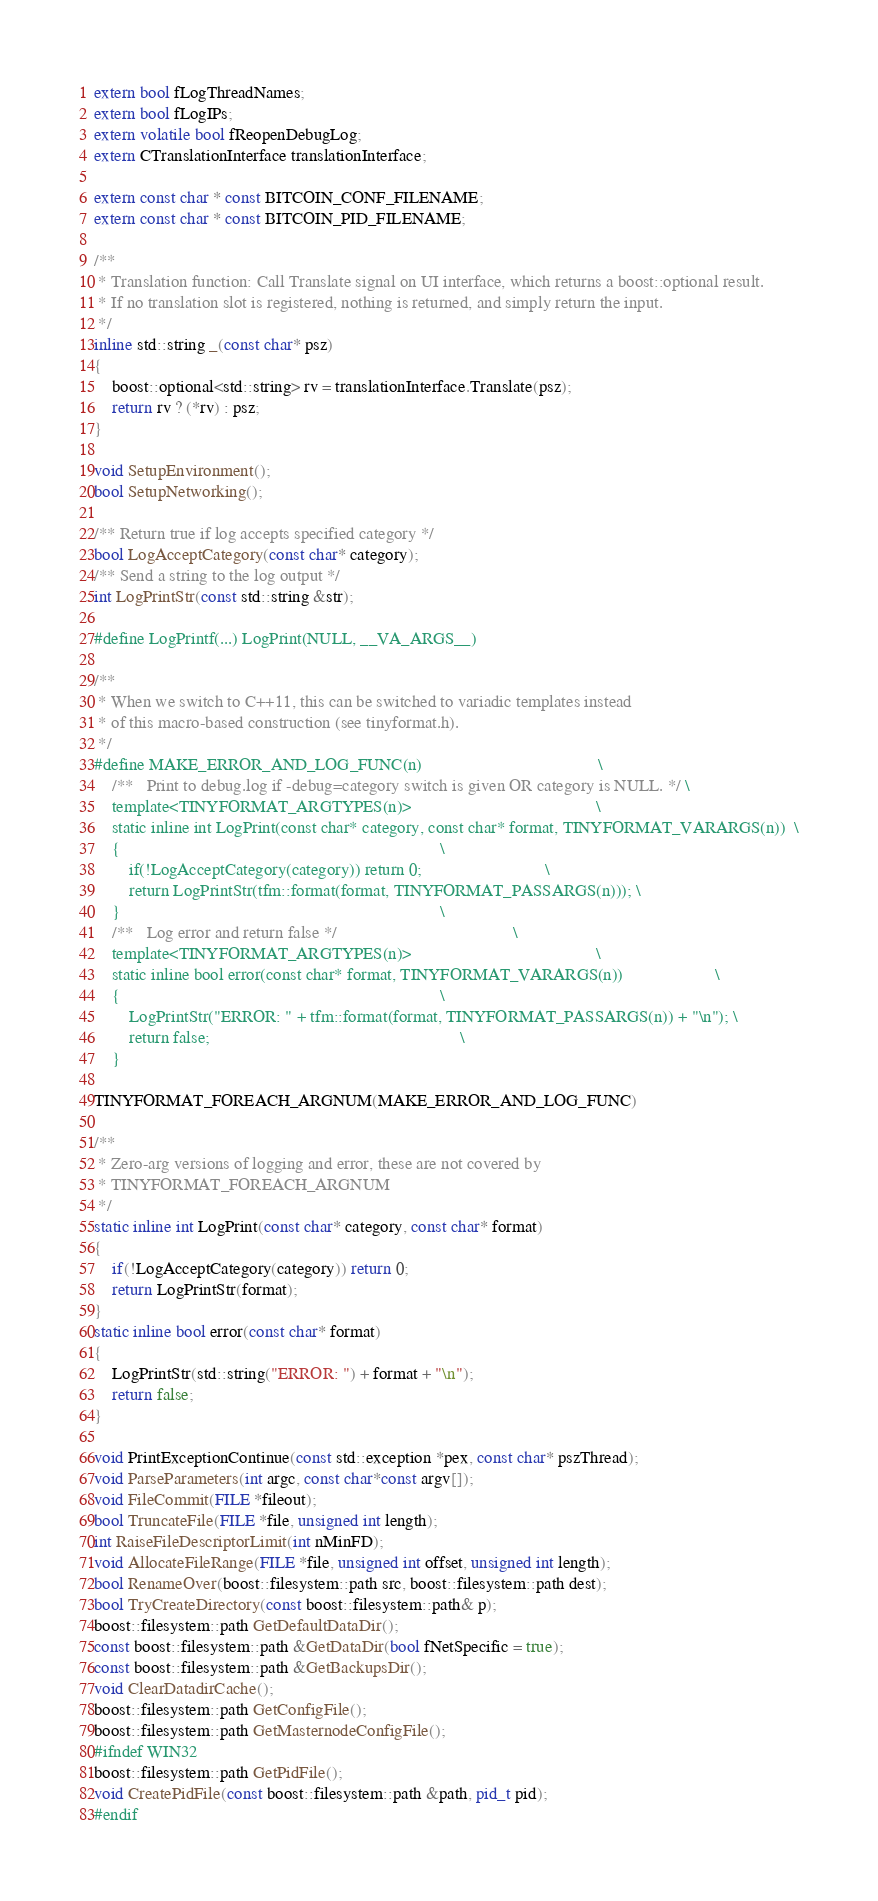Convert code to text. <code><loc_0><loc_0><loc_500><loc_500><_C_>extern bool fLogThreadNames;
extern bool fLogIPs;
extern volatile bool fReopenDebugLog;
extern CTranslationInterface translationInterface;

extern const char * const BITCOIN_CONF_FILENAME;
extern const char * const BITCOIN_PID_FILENAME;

/**
 * Translation function: Call Translate signal on UI interface, which returns a boost::optional result.
 * If no translation slot is registered, nothing is returned, and simply return the input.
 */
inline std::string _(const char* psz)
{
    boost::optional<std::string> rv = translationInterface.Translate(psz);
    return rv ? (*rv) : psz;
}

void SetupEnvironment();
bool SetupNetworking();

/** Return true if log accepts specified category */
bool LogAcceptCategory(const char* category);
/** Send a string to the log output */
int LogPrintStr(const std::string &str);

#define LogPrintf(...) LogPrint(NULL, __VA_ARGS__)

/**
 * When we switch to C++11, this can be switched to variadic templates instead
 * of this macro-based construction (see tinyformat.h).
 */
#define MAKE_ERROR_AND_LOG_FUNC(n)                                        \
    /**   Print to debug.log if -debug=category switch is given OR category is NULL. */ \
    template<TINYFORMAT_ARGTYPES(n)>                                          \
    static inline int LogPrint(const char* category, const char* format, TINYFORMAT_VARARGS(n))  \
    {                                                                         \
        if(!LogAcceptCategory(category)) return 0;                            \
        return LogPrintStr(tfm::format(format, TINYFORMAT_PASSARGS(n))); \
    }                                                                         \
    /**   Log error and return false */                                        \
    template<TINYFORMAT_ARGTYPES(n)>                                          \
    static inline bool error(const char* format, TINYFORMAT_VARARGS(n))                     \
    {                                                                         \
        LogPrintStr("ERROR: " + tfm::format(format, TINYFORMAT_PASSARGS(n)) + "\n"); \
        return false;                                                         \
    }

TINYFORMAT_FOREACH_ARGNUM(MAKE_ERROR_AND_LOG_FUNC)

/**
 * Zero-arg versions of logging and error, these are not covered by
 * TINYFORMAT_FOREACH_ARGNUM
 */
static inline int LogPrint(const char* category, const char* format)
{
    if(!LogAcceptCategory(category)) return 0;
    return LogPrintStr(format);
}
static inline bool error(const char* format)
{
    LogPrintStr(std::string("ERROR: ") + format + "\n");
    return false;
}

void PrintExceptionContinue(const std::exception *pex, const char* pszThread);
void ParseParameters(int argc, const char*const argv[]);
void FileCommit(FILE *fileout);
bool TruncateFile(FILE *file, unsigned int length);
int RaiseFileDescriptorLimit(int nMinFD);
void AllocateFileRange(FILE *file, unsigned int offset, unsigned int length);
bool RenameOver(boost::filesystem::path src, boost::filesystem::path dest);
bool TryCreateDirectory(const boost::filesystem::path& p);
boost::filesystem::path GetDefaultDataDir();
const boost::filesystem::path &GetDataDir(bool fNetSpecific = true);
const boost::filesystem::path &GetBackupsDir();
void ClearDatadirCache();
boost::filesystem::path GetConfigFile();
boost::filesystem::path GetMasternodeConfigFile();
#ifndef WIN32
boost::filesystem::path GetPidFile();
void CreatePidFile(const boost::filesystem::path &path, pid_t pid);
#endif</code> 